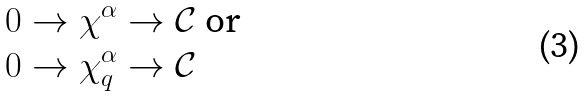Convert formula to latex. <formula><loc_0><loc_0><loc_500><loc_500>& 0 \rightarrow \chi ^ { \alpha } \rightarrow { \mathcal { C } } \text { or } \\ & 0 \rightarrow \chi ^ { \alpha } _ { q } \rightarrow { \mathcal { C } } \\</formula> 